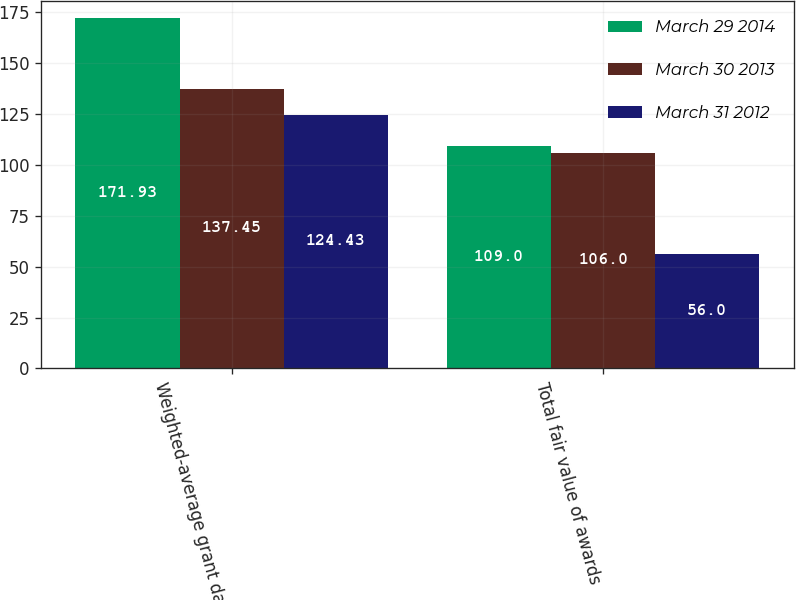Convert chart to OTSL. <chart><loc_0><loc_0><loc_500><loc_500><stacked_bar_chart><ecel><fcel>Weighted-average grant date<fcel>Total fair value of awards<nl><fcel>March 29 2014<fcel>171.93<fcel>109<nl><fcel>March 30 2013<fcel>137.45<fcel>106<nl><fcel>March 31 2012<fcel>124.43<fcel>56<nl></chart> 